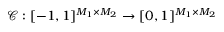<formula> <loc_0><loc_0><loc_500><loc_500>\mathcal { C } \colon [ - 1 , 1 ] ^ { M _ { 1 } \times M _ { 2 } } \to [ 0 , 1 ] ^ { M _ { 1 } \times M _ { 2 } }</formula> 